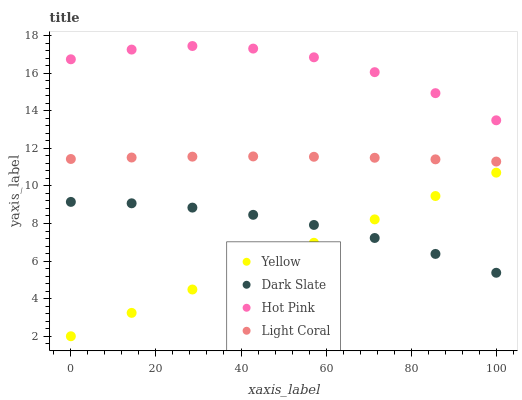Does Yellow have the minimum area under the curve?
Answer yes or no. Yes. Does Hot Pink have the maximum area under the curve?
Answer yes or no. Yes. Does Dark Slate have the minimum area under the curve?
Answer yes or no. No. Does Dark Slate have the maximum area under the curve?
Answer yes or no. No. Is Yellow the smoothest?
Answer yes or no. Yes. Is Hot Pink the roughest?
Answer yes or no. Yes. Is Dark Slate the smoothest?
Answer yes or no. No. Is Dark Slate the roughest?
Answer yes or no. No. Does Yellow have the lowest value?
Answer yes or no. Yes. Does Dark Slate have the lowest value?
Answer yes or no. No. Does Hot Pink have the highest value?
Answer yes or no. Yes. Does Dark Slate have the highest value?
Answer yes or no. No. Is Dark Slate less than Hot Pink?
Answer yes or no. Yes. Is Light Coral greater than Dark Slate?
Answer yes or no. Yes. Does Dark Slate intersect Yellow?
Answer yes or no. Yes. Is Dark Slate less than Yellow?
Answer yes or no. No. Is Dark Slate greater than Yellow?
Answer yes or no. No. Does Dark Slate intersect Hot Pink?
Answer yes or no. No. 